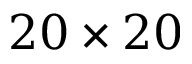<formula> <loc_0><loc_0><loc_500><loc_500>2 0 \times 2 0</formula> 